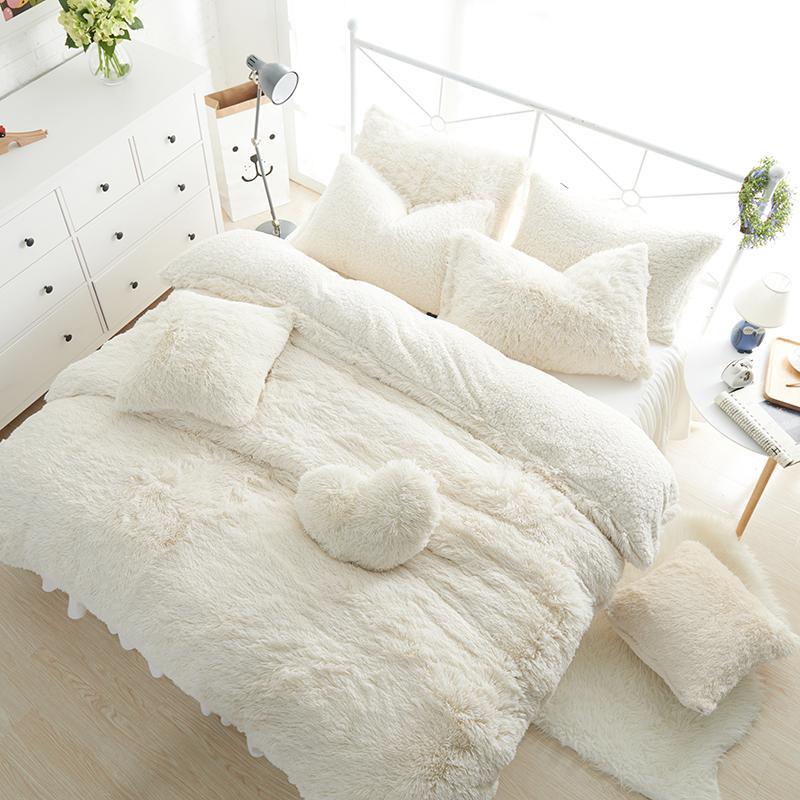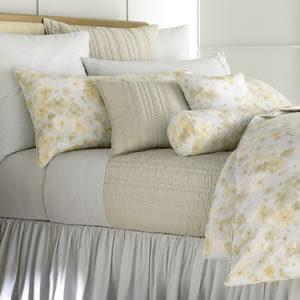The first image is the image on the left, the second image is the image on the right. Given the left and right images, does the statement "One bed has an upholstered headboard." hold true? Answer yes or no. No. 